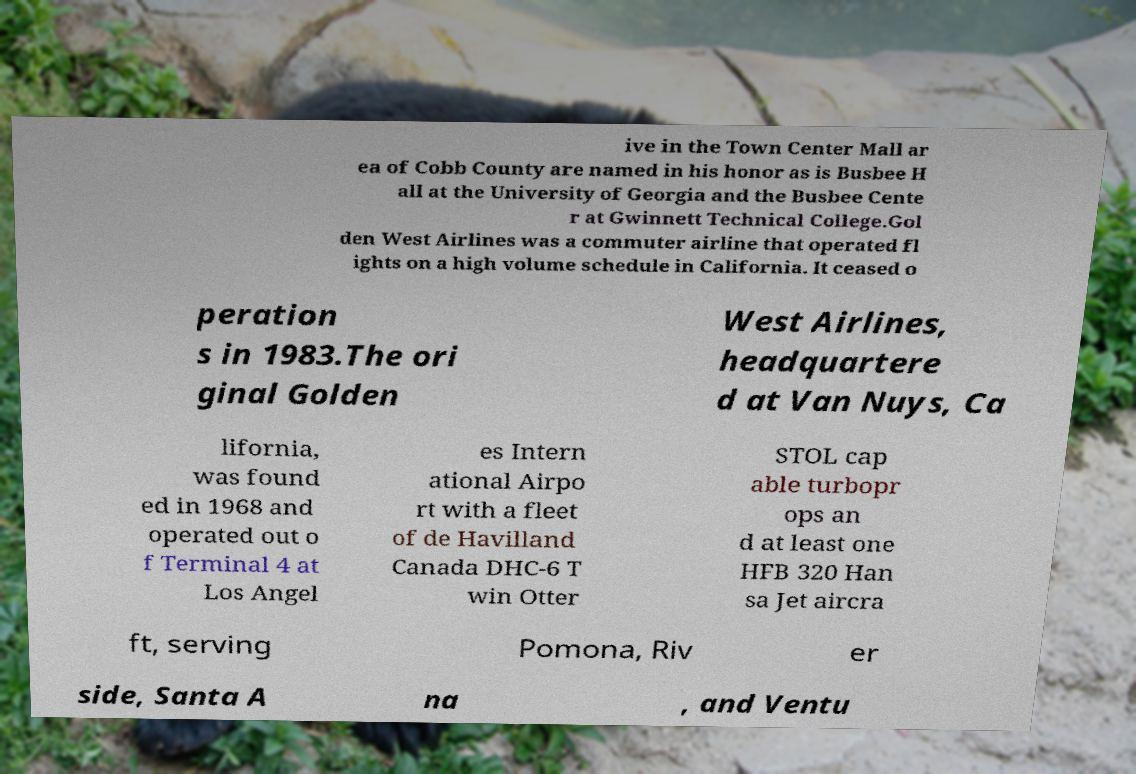What messages or text are displayed in this image? I need them in a readable, typed format. ive in the Town Center Mall ar ea of Cobb County are named in his honor as is Busbee H all at the University of Georgia and the Busbee Cente r at Gwinnett Technical College.Gol den West Airlines was a commuter airline that operated fl ights on a high volume schedule in California. It ceased o peration s in 1983.The ori ginal Golden West Airlines, headquartere d at Van Nuys, Ca lifornia, was found ed in 1968 and operated out o f Terminal 4 at Los Angel es Intern ational Airpo rt with a fleet of de Havilland Canada DHC-6 T win Otter STOL cap able turbopr ops an d at least one HFB 320 Han sa Jet aircra ft, serving Pomona, Riv er side, Santa A na , and Ventu 